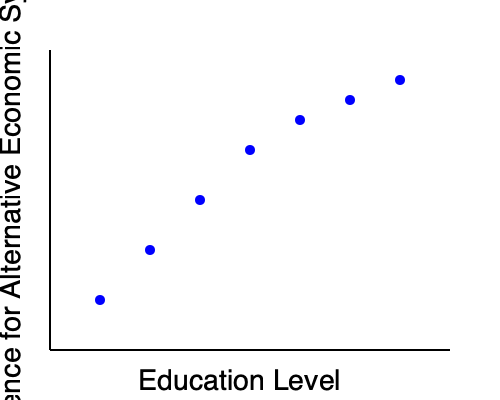Based on the scatter plot showing the relationship between education levels and preferences for alternative economic systems, what can be inferred about the correlation between these two variables? How might this trend impact policy-making in developing countries seeking to reform their economic structures? To answer this question, let's analyze the scatter plot step by step:

1. Observe the overall trend: As we move from left to right (increasing education level), the data points tend to move downward (decreasing preference for alternative economic systems).

2. Identify the correlation: This downward trend suggests a negative correlation between education level and preference for alternative economic systems.

3. Interpret the correlation: As individuals attain higher levels of education, they appear less inclined to prefer alternative economic systems.

4. Consider the strength of the correlation: The data points follow a relatively consistent pattern, indicating a moderately strong correlation.

5. Analyze potential reasons:
   a) Higher education may expose individuals to more in-depth knowledge about existing economic systems.
   b) Educational institutions might tend to teach mainstream economic theories.
   c) Higher education could lead to better job prospects within the current economic system.

6. Implications for policy-making in developing countries:
   a) Governments might face challenges in implementing alternative economic systems as education levels rise.
   b) Policy-makers may need to consider educational curricula that include diverse economic perspectives.
   c) Economic reforms might need to be gradual and accompanied by public education campaigns.
   d) Countries may need to balance economic innovation with the expectations of an increasingly educated workforce.

7. Limitations to consider:
   a) Correlation does not imply causation; other factors may influence this relationship.
   b) The sample size and diversity are not specified, which could affect the reliability of the inference.
   c) Cultural and regional differences may impact this relationship differently across various contexts.

In conclusion, the data suggests that as education levels increase, preference for alternative economic systems tends to decrease, which could present challenges for developing countries seeking to implement significant economic reforms.
Answer: Negative correlation between education and alternative economic system preference, potentially challenging economic reforms in developing countries. 